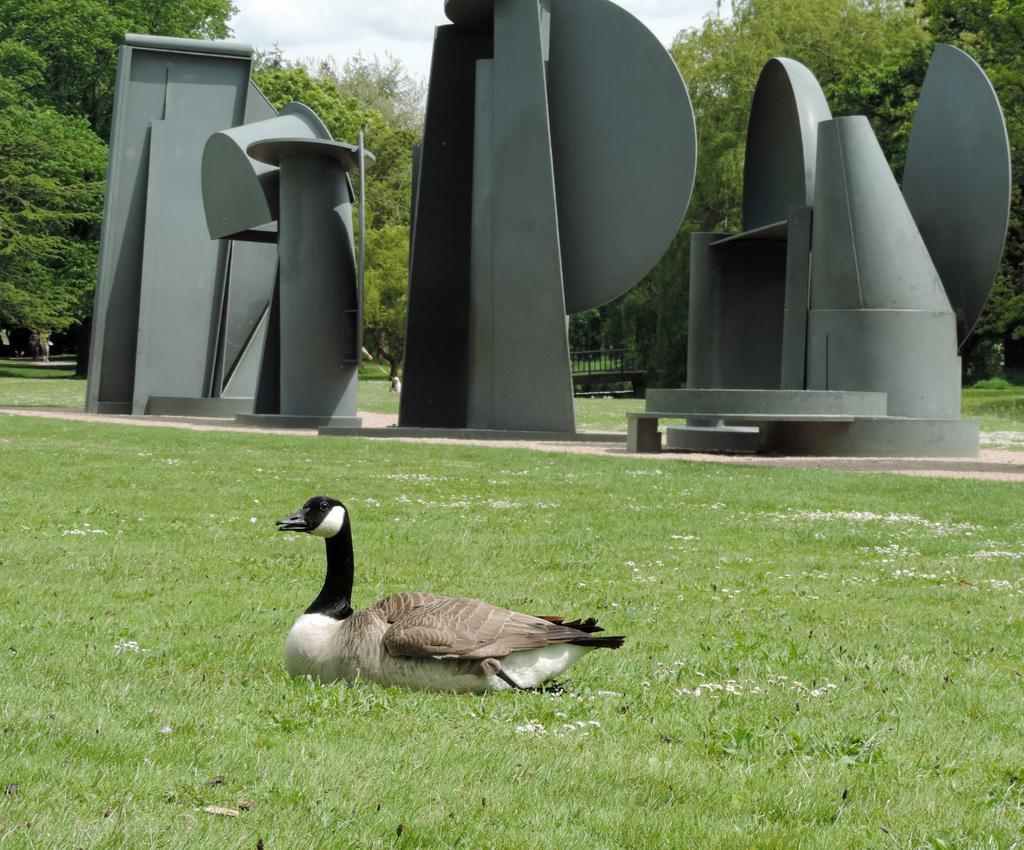Could you give a brief overview of what you see in this image? In this image, we can see a bird. We can see the ground. We can see some grass. There are a few trees and structures. We can see the fence and the sky. 